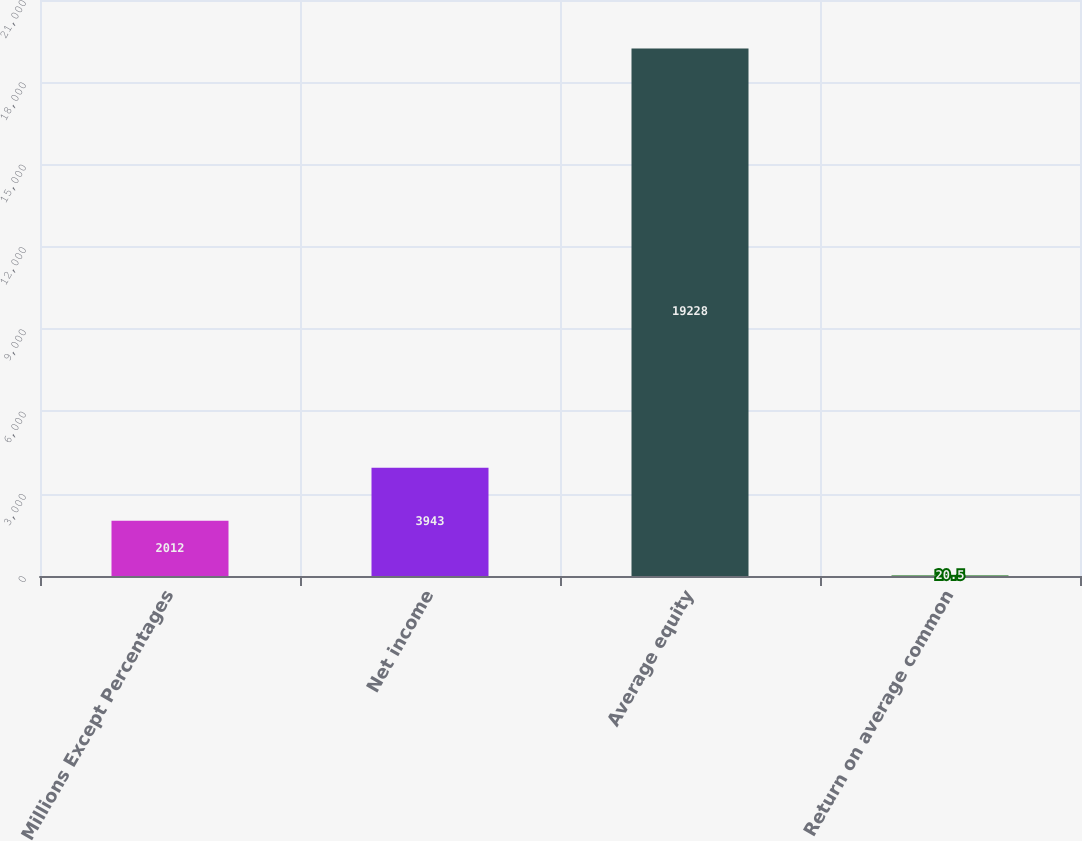<chart> <loc_0><loc_0><loc_500><loc_500><bar_chart><fcel>Millions Except Percentages<fcel>Net income<fcel>Average equity<fcel>Return on average common<nl><fcel>2012<fcel>3943<fcel>19228<fcel>20.5<nl></chart> 